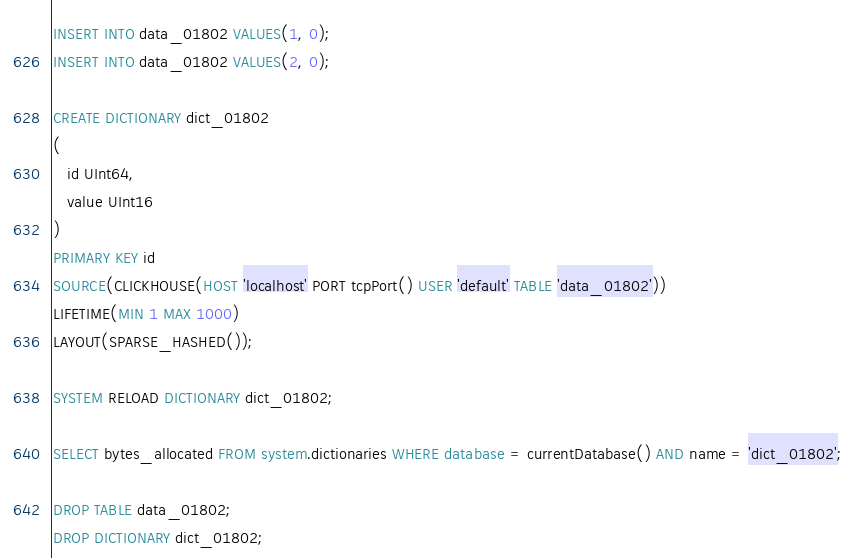<code> <loc_0><loc_0><loc_500><loc_500><_SQL_>INSERT INTO data_01802 VALUES(1, 0);
INSERT INTO data_01802 VALUES(2, 0);

CREATE DICTIONARY dict_01802
(
   id UInt64,
   value UInt16
)
PRIMARY KEY id
SOURCE(CLICKHOUSE(HOST 'localhost' PORT tcpPort() USER 'default' TABLE 'data_01802'))
LIFETIME(MIN 1 MAX 1000)
LAYOUT(SPARSE_HASHED());

SYSTEM RELOAD DICTIONARY dict_01802;

SELECT bytes_allocated FROM system.dictionaries WHERE database = currentDatabase() AND name = 'dict_01802';

DROP TABLE data_01802;
DROP DICTIONARY dict_01802;
</code> 